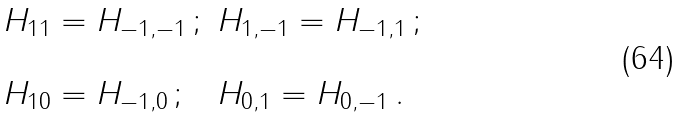Convert formula to latex. <formula><loc_0><loc_0><loc_500><loc_500>\begin{array} { l l } H _ { 1 1 } = H _ { - 1 , - 1 } \, ; & H _ { 1 , - 1 } = H _ { - 1 , 1 } \, ; \\ & \\ H _ { 1 0 } = H _ { - 1 , 0 } \, ; & H _ { 0 , 1 } = H _ { 0 , - 1 } \, . \end{array}</formula> 